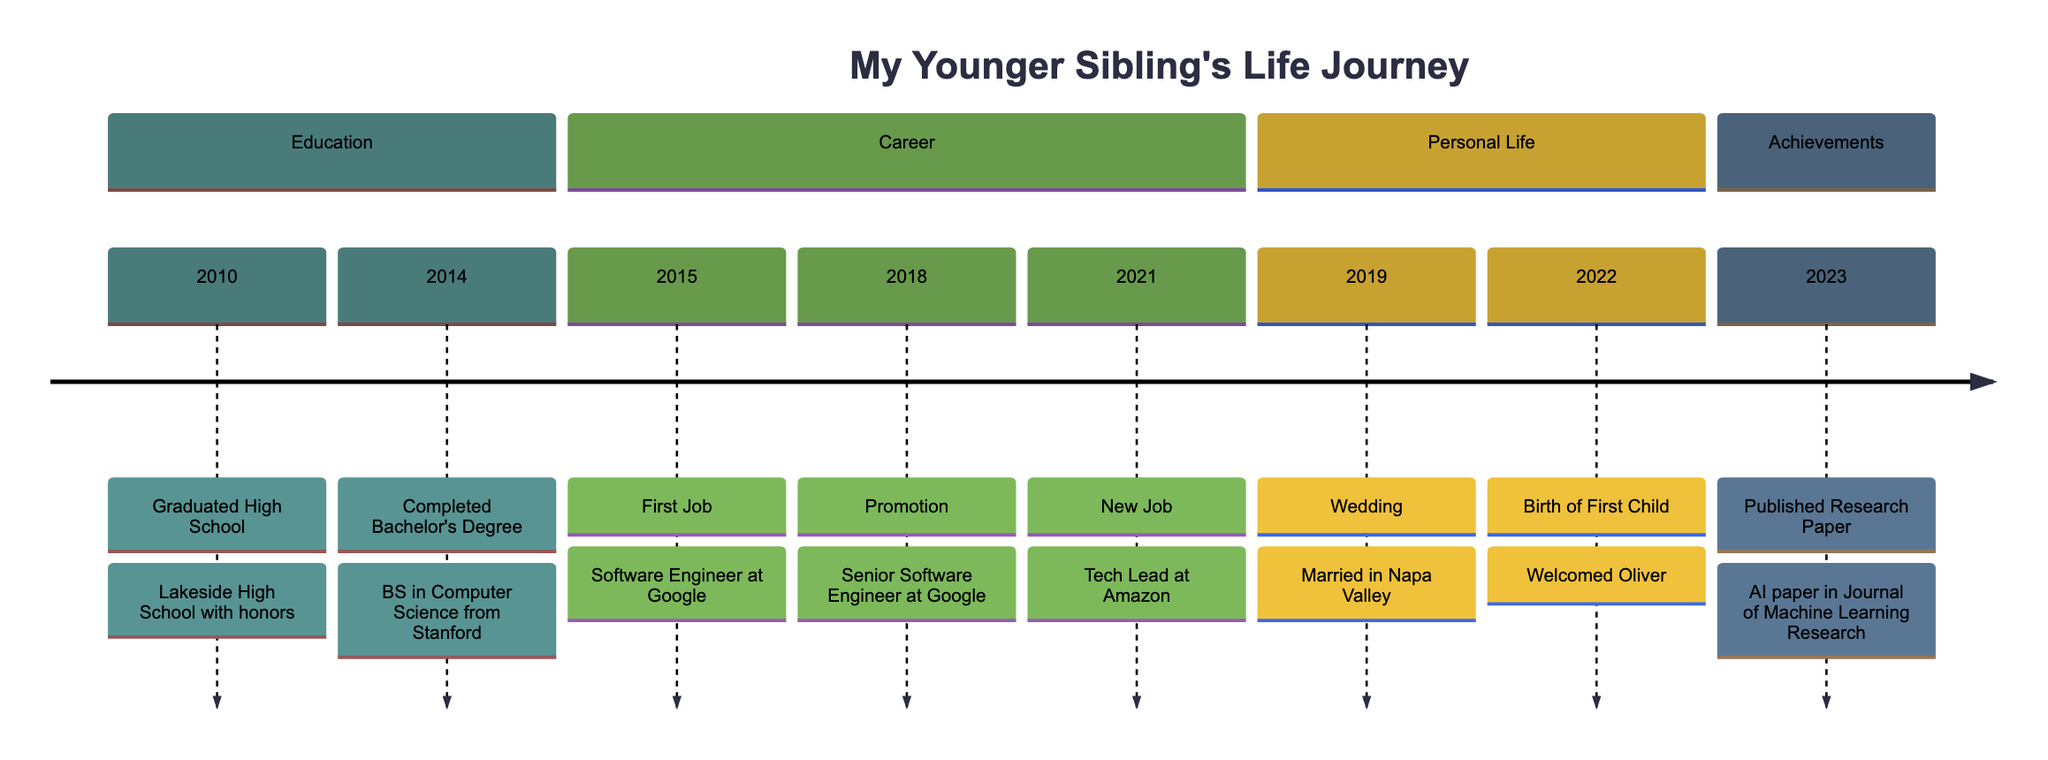What event occurred in 2014? In the timeline, the event listed for 2014 is "Completed Bachelor's Degree." This is found in the Education section, right above any events from the Career section.
Answer: Completed Bachelor's Degree How many promotions did your younger sibling receive? The timeline shows one promotion event listed in 2018, "Promotion." This indicates that they were promoted to a Senior Software Engineer at Google.
Answer: One promotion What was your sibling's first job title? The first job listed in the timeline is in 2015, titled "First Job," where your sibling worked as a Software Engineer at Google. This is explicitly mentioned in the Career section.
Answer: Software Engineer In which year was your sibling's first child born? The timeline states that the "Birth of First Child" event took place in 2022. This event is located in the Personal Life section following their wedding in 2019.
Answer: 2022 What major academic achievement did your sibling accomplish in 2023? According to the timeline, the major achievement in 2023 is the "Published Research Paper," which reflects a significant contribution to the field of artificial intelligence. It is found in the Achievements section.
Answer: Published Research Paper Which company did your sibling start a new job with in 2021? The timeline notes that in 2021, your sibling began a new role as a Tech Lead at Amazon, which is indicated as a separate key event in the Career section.
Answer: Amazon What is the relationship between the wedding and the birth of the first child events? Analyzing the timeline, the wedding took place in 2019, followed by the birth of the first child in 2022. This indicates a lapse of three years between these two significant personal life events.
Answer: Three years Where did your sibling graduate high school? The timeline item for graduating high school (2010) specifies that your sibling graduated from "Lakeside High School with honors," which provides a clear answer to the educational institution.
Answer: Lakeside High School What is the total number of major life events listed? Counting all distinct events on the timeline—ranging from academic achievements, career milestones, personal life events, to achievements—there are a total of eight events documented.
Answer: Eight events 